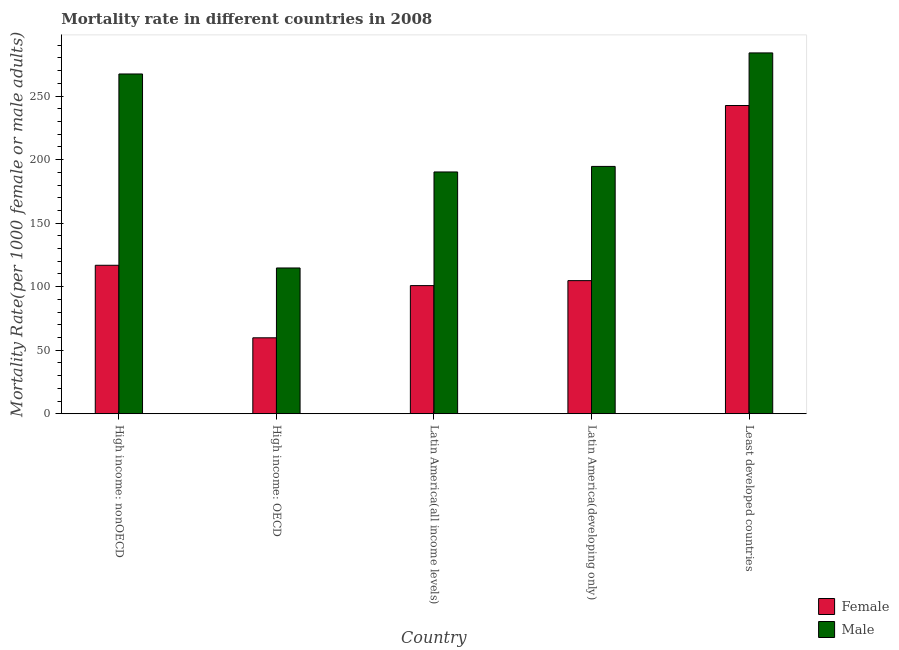How many different coloured bars are there?
Your response must be concise. 2. Are the number of bars per tick equal to the number of legend labels?
Provide a succinct answer. Yes. Are the number of bars on each tick of the X-axis equal?
Keep it short and to the point. Yes. What is the label of the 5th group of bars from the left?
Offer a very short reply. Least developed countries. What is the female mortality rate in Least developed countries?
Make the answer very short. 242.59. Across all countries, what is the maximum female mortality rate?
Offer a terse response. 242.59. Across all countries, what is the minimum female mortality rate?
Offer a terse response. 59.76. In which country was the male mortality rate maximum?
Your answer should be compact. Least developed countries. In which country was the female mortality rate minimum?
Provide a short and direct response. High income: OECD. What is the total male mortality rate in the graph?
Offer a terse response. 1051.06. What is the difference between the male mortality rate in High income: nonOECD and that in Latin America(all income levels)?
Make the answer very short. 77.12. What is the difference between the female mortality rate in Latin America(developing only) and the male mortality rate in High income: nonOECD?
Give a very brief answer. -162.65. What is the average female mortality rate per country?
Offer a terse response. 124.96. What is the difference between the female mortality rate and male mortality rate in Latin America(all income levels)?
Offer a terse response. -89.43. In how many countries, is the male mortality rate greater than 200 ?
Your answer should be compact. 2. What is the ratio of the male mortality rate in High income: OECD to that in Latin America(all income levels)?
Offer a terse response. 0.6. Is the male mortality rate in Latin America(all income levels) less than that in Latin America(developing only)?
Offer a terse response. Yes. What is the difference between the highest and the second highest male mortality rate?
Your response must be concise. 16.57. What is the difference between the highest and the lowest male mortality rate?
Ensure brevity in your answer.  169.26. Are the values on the major ticks of Y-axis written in scientific E-notation?
Your answer should be very brief. No. Does the graph contain grids?
Offer a very short reply. No. Where does the legend appear in the graph?
Your answer should be compact. Bottom right. How many legend labels are there?
Make the answer very short. 2. How are the legend labels stacked?
Your response must be concise. Vertical. What is the title of the graph?
Provide a short and direct response. Mortality rate in different countries in 2008. What is the label or title of the Y-axis?
Make the answer very short. Mortality Rate(per 1000 female or male adults). What is the Mortality Rate(per 1000 female or male adults) of Female in High income: nonOECD?
Make the answer very short. 116.85. What is the Mortality Rate(per 1000 female or male adults) in Male in High income: nonOECD?
Provide a succinct answer. 267.41. What is the Mortality Rate(per 1000 female or male adults) of Female in High income: OECD?
Keep it short and to the point. 59.76. What is the Mortality Rate(per 1000 female or male adults) in Male in High income: OECD?
Keep it short and to the point. 114.73. What is the Mortality Rate(per 1000 female or male adults) of Female in Latin America(all income levels)?
Make the answer very short. 100.85. What is the Mortality Rate(per 1000 female or male adults) in Male in Latin America(all income levels)?
Give a very brief answer. 190.29. What is the Mortality Rate(per 1000 female or male adults) in Female in Latin America(developing only)?
Ensure brevity in your answer.  104.76. What is the Mortality Rate(per 1000 female or male adults) of Male in Latin America(developing only)?
Offer a terse response. 194.65. What is the Mortality Rate(per 1000 female or male adults) in Female in Least developed countries?
Offer a very short reply. 242.59. What is the Mortality Rate(per 1000 female or male adults) of Male in Least developed countries?
Provide a short and direct response. 283.98. Across all countries, what is the maximum Mortality Rate(per 1000 female or male adults) of Female?
Make the answer very short. 242.59. Across all countries, what is the maximum Mortality Rate(per 1000 female or male adults) in Male?
Your response must be concise. 283.98. Across all countries, what is the minimum Mortality Rate(per 1000 female or male adults) in Female?
Make the answer very short. 59.76. Across all countries, what is the minimum Mortality Rate(per 1000 female or male adults) of Male?
Offer a terse response. 114.73. What is the total Mortality Rate(per 1000 female or male adults) in Female in the graph?
Your answer should be compact. 624.81. What is the total Mortality Rate(per 1000 female or male adults) of Male in the graph?
Your answer should be very brief. 1051.06. What is the difference between the Mortality Rate(per 1000 female or male adults) in Female in High income: nonOECD and that in High income: OECD?
Provide a short and direct response. 57.09. What is the difference between the Mortality Rate(per 1000 female or male adults) of Male in High income: nonOECD and that in High income: OECD?
Your answer should be very brief. 152.69. What is the difference between the Mortality Rate(per 1000 female or male adults) of Female in High income: nonOECD and that in Latin America(all income levels)?
Keep it short and to the point. 15.99. What is the difference between the Mortality Rate(per 1000 female or male adults) of Male in High income: nonOECD and that in Latin America(all income levels)?
Offer a terse response. 77.12. What is the difference between the Mortality Rate(per 1000 female or male adults) in Female in High income: nonOECD and that in Latin America(developing only)?
Make the answer very short. 12.09. What is the difference between the Mortality Rate(per 1000 female or male adults) of Male in High income: nonOECD and that in Latin America(developing only)?
Your answer should be very brief. 72.76. What is the difference between the Mortality Rate(per 1000 female or male adults) in Female in High income: nonOECD and that in Least developed countries?
Provide a succinct answer. -125.74. What is the difference between the Mortality Rate(per 1000 female or male adults) of Male in High income: nonOECD and that in Least developed countries?
Your answer should be compact. -16.57. What is the difference between the Mortality Rate(per 1000 female or male adults) of Female in High income: OECD and that in Latin America(all income levels)?
Your answer should be very brief. -41.1. What is the difference between the Mortality Rate(per 1000 female or male adults) in Male in High income: OECD and that in Latin America(all income levels)?
Your response must be concise. -75.56. What is the difference between the Mortality Rate(per 1000 female or male adults) in Female in High income: OECD and that in Latin America(developing only)?
Offer a terse response. -45. What is the difference between the Mortality Rate(per 1000 female or male adults) of Male in High income: OECD and that in Latin America(developing only)?
Offer a very short reply. -79.93. What is the difference between the Mortality Rate(per 1000 female or male adults) in Female in High income: OECD and that in Least developed countries?
Provide a succinct answer. -182.83. What is the difference between the Mortality Rate(per 1000 female or male adults) in Male in High income: OECD and that in Least developed countries?
Provide a succinct answer. -169.26. What is the difference between the Mortality Rate(per 1000 female or male adults) of Female in Latin America(all income levels) and that in Latin America(developing only)?
Provide a succinct answer. -3.9. What is the difference between the Mortality Rate(per 1000 female or male adults) in Male in Latin America(all income levels) and that in Latin America(developing only)?
Offer a very short reply. -4.37. What is the difference between the Mortality Rate(per 1000 female or male adults) of Female in Latin America(all income levels) and that in Least developed countries?
Provide a succinct answer. -141.74. What is the difference between the Mortality Rate(per 1000 female or male adults) of Male in Latin America(all income levels) and that in Least developed countries?
Your answer should be very brief. -93.7. What is the difference between the Mortality Rate(per 1000 female or male adults) of Female in Latin America(developing only) and that in Least developed countries?
Provide a short and direct response. -137.84. What is the difference between the Mortality Rate(per 1000 female or male adults) in Male in Latin America(developing only) and that in Least developed countries?
Your answer should be compact. -89.33. What is the difference between the Mortality Rate(per 1000 female or male adults) in Female in High income: nonOECD and the Mortality Rate(per 1000 female or male adults) in Male in High income: OECD?
Give a very brief answer. 2.12. What is the difference between the Mortality Rate(per 1000 female or male adults) of Female in High income: nonOECD and the Mortality Rate(per 1000 female or male adults) of Male in Latin America(all income levels)?
Your response must be concise. -73.44. What is the difference between the Mortality Rate(per 1000 female or male adults) of Female in High income: nonOECD and the Mortality Rate(per 1000 female or male adults) of Male in Latin America(developing only)?
Your answer should be compact. -77.81. What is the difference between the Mortality Rate(per 1000 female or male adults) of Female in High income: nonOECD and the Mortality Rate(per 1000 female or male adults) of Male in Least developed countries?
Keep it short and to the point. -167.13. What is the difference between the Mortality Rate(per 1000 female or male adults) in Female in High income: OECD and the Mortality Rate(per 1000 female or male adults) in Male in Latin America(all income levels)?
Your answer should be very brief. -130.53. What is the difference between the Mortality Rate(per 1000 female or male adults) of Female in High income: OECD and the Mortality Rate(per 1000 female or male adults) of Male in Latin America(developing only)?
Offer a very short reply. -134.9. What is the difference between the Mortality Rate(per 1000 female or male adults) in Female in High income: OECD and the Mortality Rate(per 1000 female or male adults) in Male in Least developed countries?
Your answer should be very brief. -224.22. What is the difference between the Mortality Rate(per 1000 female or male adults) of Female in Latin America(all income levels) and the Mortality Rate(per 1000 female or male adults) of Male in Latin America(developing only)?
Make the answer very short. -93.8. What is the difference between the Mortality Rate(per 1000 female or male adults) in Female in Latin America(all income levels) and the Mortality Rate(per 1000 female or male adults) in Male in Least developed countries?
Your response must be concise. -183.13. What is the difference between the Mortality Rate(per 1000 female or male adults) of Female in Latin America(developing only) and the Mortality Rate(per 1000 female or male adults) of Male in Least developed countries?
Ensure brevity in your answer.  -179.22. What is the average Mortality Rate(per 1000 female or male adults) in Female per country?
Make the answer very short. 124.96. What is the average Mortality Rate(per 1000 female or male adults) in Male per country?
Offer a very short reply. 210.21. What is the difference between the Mortality Rate(per 1000 female or male adults) of Female and Mortality Rate(per 1000 female or male adults) of Male in High income: nonOECD?
Ensure brevity in your answer.  -150.56. What is the difference between the Mortality Rate(per 1000 female or male adults) in Female and Mortality Rate(per 1000 female or male adults) in Male in High income: OECD?
Give a very brief answer. -54.97. What is the difference between the Mortality Rate(per 1000 female or male adults) of Female and Mortality Rate(per 1000 female or male adults) of Male in Latin America(all income levels)?
Make the answer very short. -89.43. What is the difference between the Mortality Rate(per 1000 female or male adults) in Female and Mortality Rate(per 1000 female or male adults) in Male in Latin America(developing only)?
Make the answer very short. -89.9. What is the difference between the Mortality Rate(per 1000 female or male adults) of Female and Mortality Rate(per 1000 female or male adults) of Male in Least developed countries?
Your response must be concise. -41.39. What is the ratio of the Mortality Rate(per 1000 female or male adults) of Female in High income: nonOECD to that in High income: OECD?
Make the answer very short. 1.96. What is the ratio of the Mortality Rate(per 1000 female or male adults) of Male in High income: nonOECD to that in High income: OECD?
Make the answer very short. 2.33. What is the ratio of the Mortality Rate(per 1000 female or male adults) in Female in High income: nonOECD to that in Latin America(all income levels)?
Offer a terse response. 1.16. What is the ratio of the Mortality Rate(per 1000 female or male adults) of Male in High income: nonOECD to that in Latin America(all income levels)?
Offer a very short reply. 1.41. What is the ratio of the Mortality Rate(per 1000 female or male adults) of Female in High income: nonOECD to that in Latin America(developing only)?
Keep it short and to the point. 1.12. What is the ratio of the Mortality Rate(per 1000 female or male adults) in Male in High income: nonOECD to that in Latin America(developing only)?
Make the answer very short. 1.37. What is the ratio of the Mortality Rate(per 1000 female or male adults) in Female in High income: nonOECD to that in Least developed countries?
Give a very brief answer. 0.48. What is the ratio of the Mortality Rate(per 1000 female or male adults) in Male in High income: nonOECD to that in Least developed countries?
Provide a short and direct response. 0.94. What is the ratio of the Mortality Rate(per 1000 female or male adults) in Female in High income: OECD to that in Latin America(all income levels)?
Offer a terse response. 0.59. What is the ratio of the Mortality Rate(per 1000 female or male adults) in Male in High income: OECD to that in Latin America(all income levels)?
Your response must be concise. 0.6. What is the ratio of the Mortality Rate(per 1000 female or male adults) of Female in High income: OECD to that in Latin America(developing only)?
Your answer should be very brief. 0.57. What is the ratio of the Mortality Rate(per 1000 female or male adults) of Male in High income: OECD to that in Latin America(developing only)?
Make the answer very short. 0.59. What is the ratio of the Mortality Rate(per 1000 female or male adults) in Female in High income: OECD to that in Least developed countries?
Offer a very short reply. 0.25. What is the ratio of the Mortality Rate(per 1000 female or male adults) of Male in High income: OECD to that in Least developed countries?
Give a very brief answer. 0.4. What is the ratio of the Mortality Rate(per 1000 female or male adults) in Female in Latin America(all income levels) to that in Latin America(developing only)?
Provide a short and direct response. 0.96. What is the ratio of the Mortality Rate(per 1000 female or male adults) in Male in Latin America(all income levels) to that in Latin America(developing only)?
Offer a terse response. 0.98. What is the ratio of the Mortality Rate(per 1000 female or male adults) of Female in Latin America(all income levels) to that in Least developed countries?
Offer a terse response. 0.42. What is the ratio of the Mortality Rate(per 1000 female or male adults) of Male in Latin America(all income levels) to that in Least developed countries?
Make the answer very short. 0.67. What is the ratio of the Mortality Rate(per 1000 female or male adults) of Female in Latin America(developing only) to that in Least developed countries?
Make the answer very short. 0.43. What is the ratio of the Mortality Rate(per 1000 female or male adults) in Male in Latin America(developing only) to that in Least developed countries?
Your answer should be very brief. 0.69. What is the difference between the highest and the second highest Mortality Rate(per 1000 female or male adults) in Female?
Make the answer very short. 125.74. What is the difference between the highest and the second highest Mortality Rate(per 1000 female or male adults) in Male?
Your answer should be very brief. 16.57. What is the difference between the highest and the lowest Mortality Rate(per 1000 female or male adults) in Female?
Your answer should be compact. 182.83. What is the difference between the highest and the lowest Mortality Rate(per 1000 female or male adults) in Male?
Offer a very short reply. 169.26. 